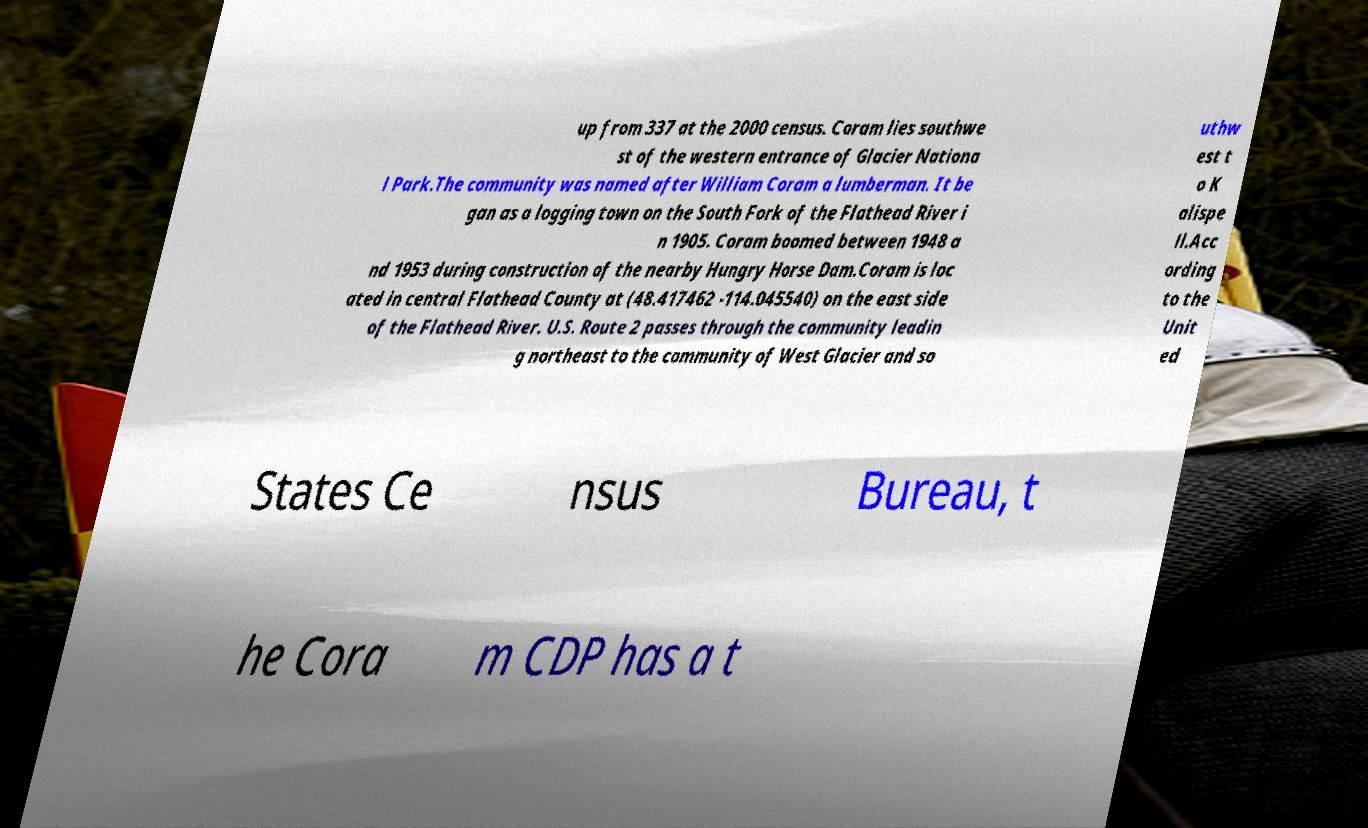Can you read and provide the text displayed in the image?This photo seems to have some interesting text. Can you extract and type it out for me? up from 337 at the 2000 census. Coram lies southwe st of the western entrance of Glacier Nationa l Park.The community was named after William Coram a lumberman. It be gan as a logging town on the South Fork of the Flathead River i n 1905. Coram boomed between 1948 a nd 1953 during construction of the nearby Hungry Horse Dam.Coram is loc ated in central Flathead County at (48.417462 -114.045540) on the east side of the Flathead River. U.S. Route 2 passes through the community leadin g northeast to the community of West Glacier and so uthw est t o K alispe ll.Acc ording to the Unit ed States Ce nsus Bureau, t he Cora m CDP has a t 